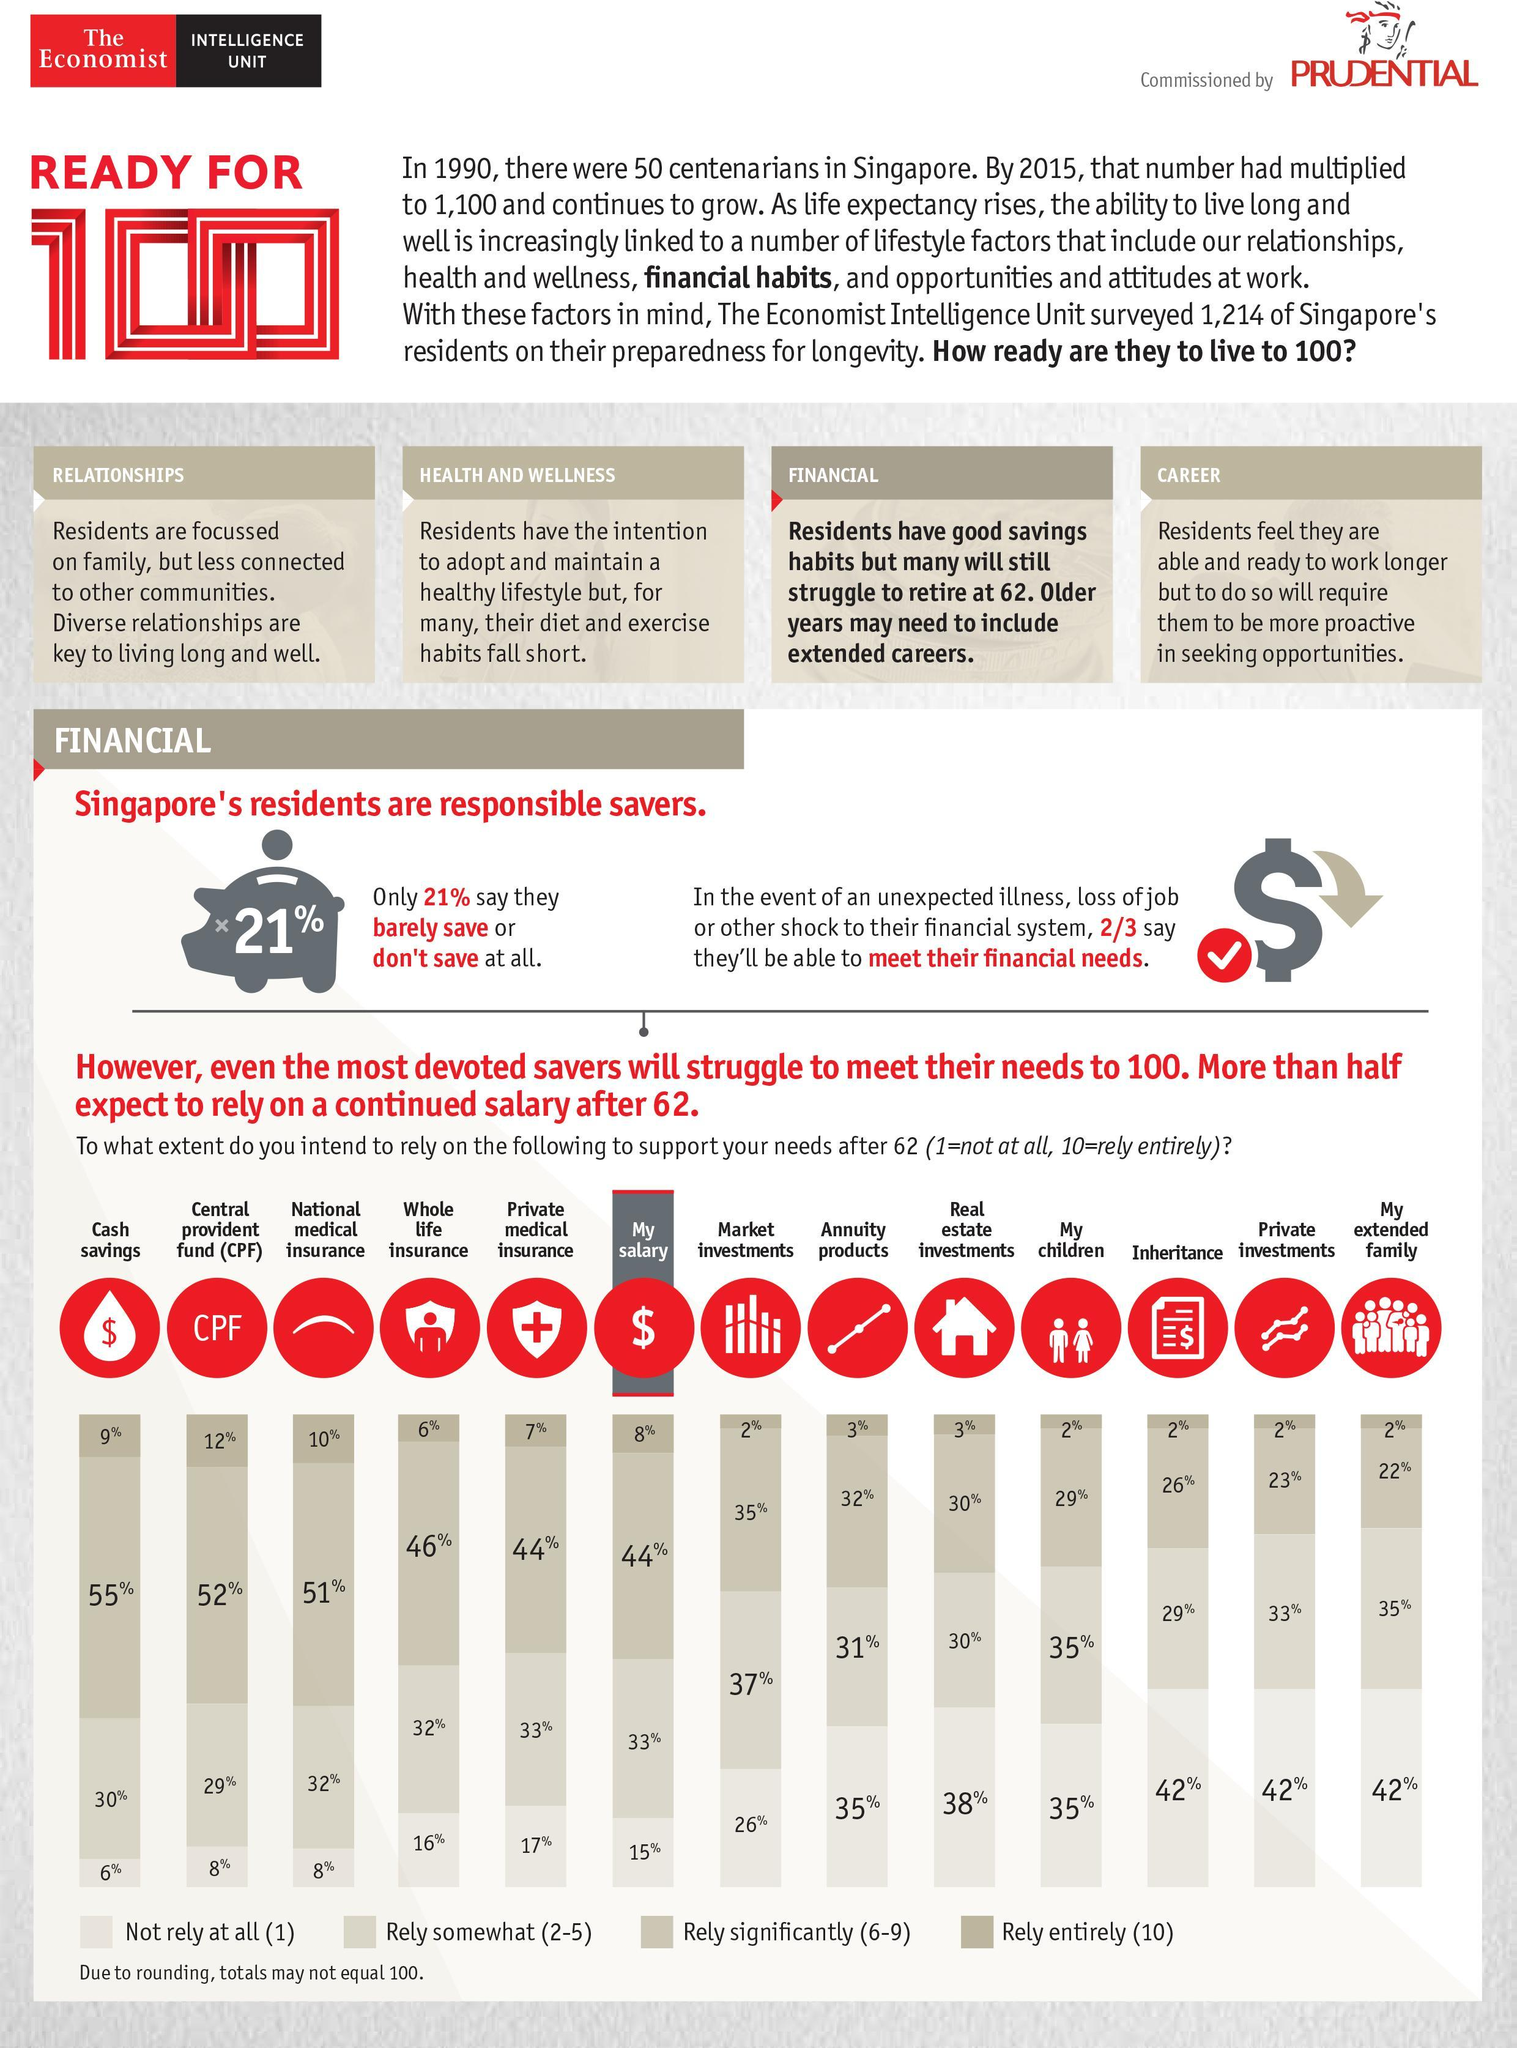On what will 51% of people rely significantly?
Answer the question with a short phrase. National medical insurance What percent of people will rely entirely on cash savings? 9% What percent of people will rely somewhat on their salary? 33% What percent of people will not rely on their children at all? 35% What percent of Singapore's residents are able to save? 79% What percent of people will rely significantly on Annuity products? 32% What proportion of residents are unable to meet their financial needs in case of emergency? 1/3 